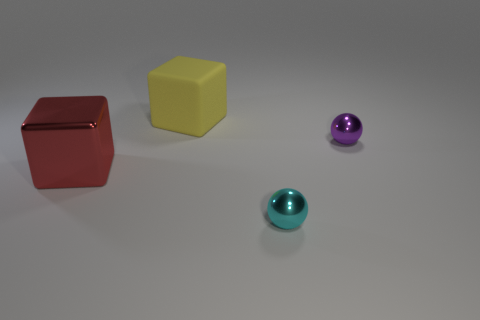Which objects in the image seem to have reflective surfaces? The two spheres appear to have reflective surfaces, evident by the way they catch the light and the subtle reflections visible on their surfaces. 